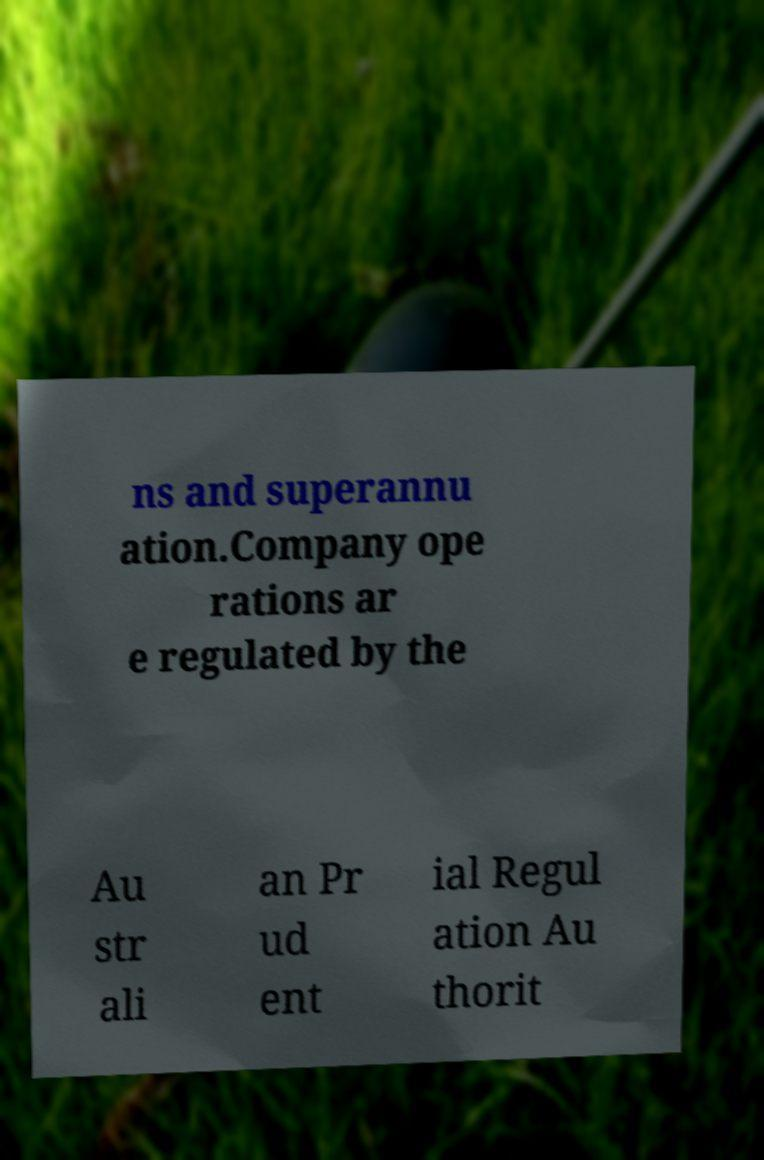Could you assist in decoding the text presented in this image and type it out clearly? ns and superannu ation.Company ope rations ar e regulated by the Au str ali an Pr ud ent ial Regul ation Au thorit 